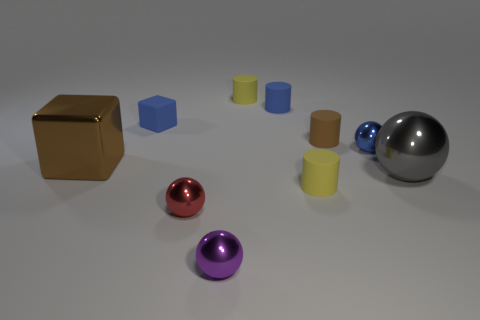Does the yellow thing behind the large ball have the same shape as the small blue metal object?
Provide a short and direct response. No. What number of tiny things are both to the left of the purple sphere and behind the red object?
Your answer should be compact. 1. What material is the small purple object?
Provide a short and direct response. Metal. Is there any other thing that has the same color as the rubber block?
Provide a succinct answer. Yes. Is the small block made of the same material as the small brown cylinder?
Ensure brevity in your answer.  Yes. There is a yellow thing behind the tiny brown rubber cylinder to the right of the red sphere; how many shiny objects are to the left of it?
Your answer should be compact. 3. What number of small shiny cubes are there?
Provide a short and direct response. 0. Are there fewer small objects behind the tiny purple object than things that are left of the gray sphere?
Provide a short and direct response. Yes. Is the number of big brown metallic things that are in front of the brown rubber cylinder less than the number of tiny blue things?
Offer a very short reply. Yes. There is a brown thing right of the big thing left of the tiny rubber object in front of the blue ball; what is its material?
Ensure brevity in your answer.  Rubber. 